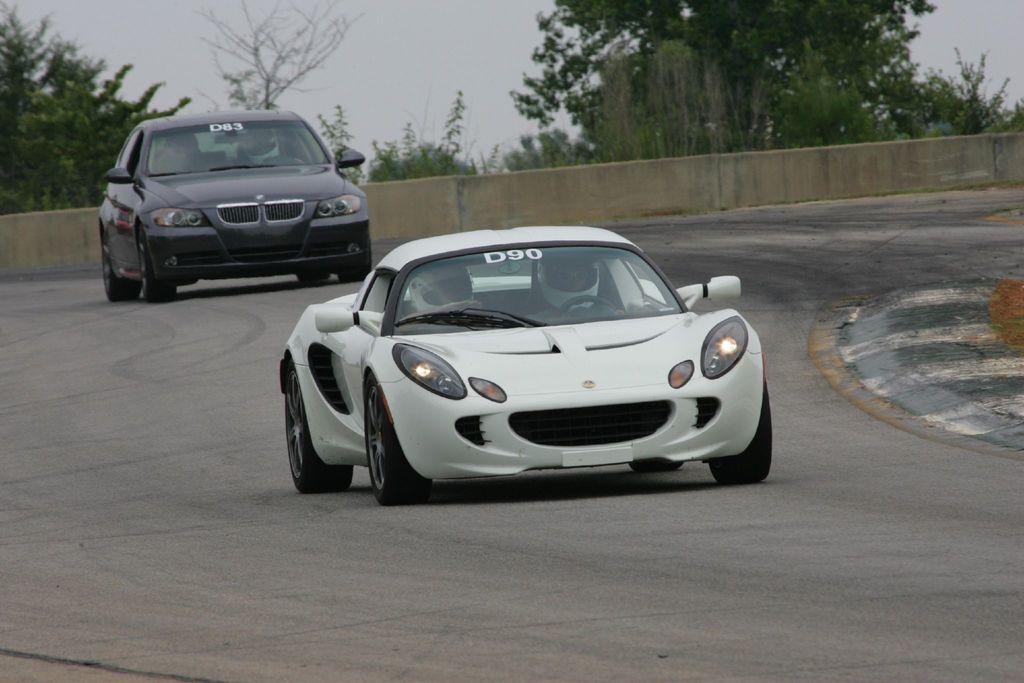How would you summarize this image in a sentence or two? In this image we can see two person sitting inside the white car. On the back we can see a black car which is on the road. On the background we can see wall and many trees. On the top we can see sky and clouds. 